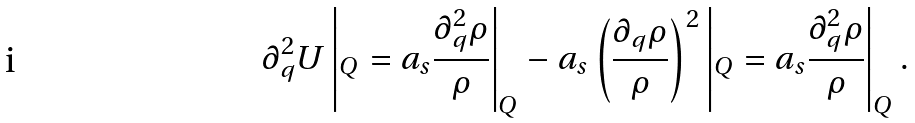<formula> <loc_0><loc_0><loc_500><loc_500>\partial _ { q } ^ { 2 } U \left | _ { Q } = a _ { s } \frac { \partial _ { q } ^ { 2 } \rho } { \rho } \right | _ { Q } - a _ { s } \left ( \frac { \partial _ { q } \rho } { \rho } \right ) ^ { 2 } \left | _ { Q } = a _ { s } \frac { \partial _ { q } ^ { 2 } \rho } { \rho } \right | _ { Q } .</formula> 